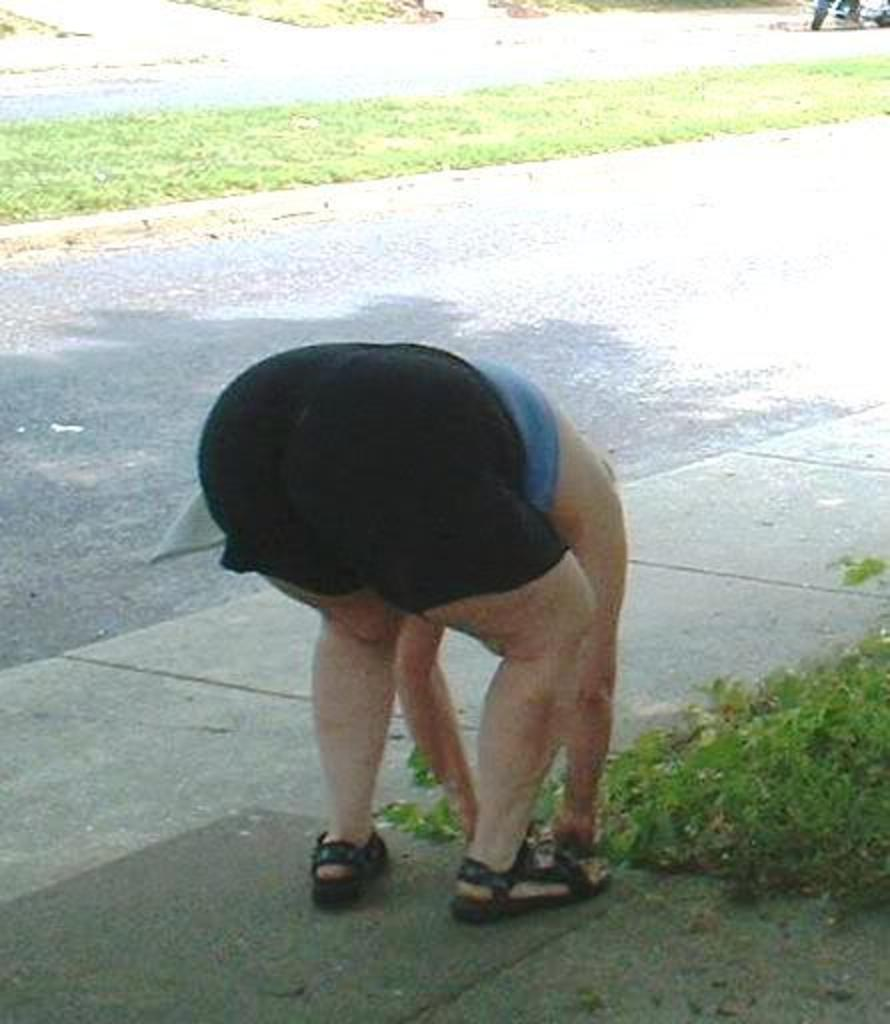What type of surface can be seen in the image? There is a road in the image. What type of vegetation is present in the image? There is grass in the image. What can be observed in the image that indicates the presence of light? There is a shadow in the image. Can you identify any living being in the image? There is a person in the image. What type of fowl can be seen in the image? There is no fowl present in the image. How does the person in the image look? The image does not provide information about the person's appearance or expression. 